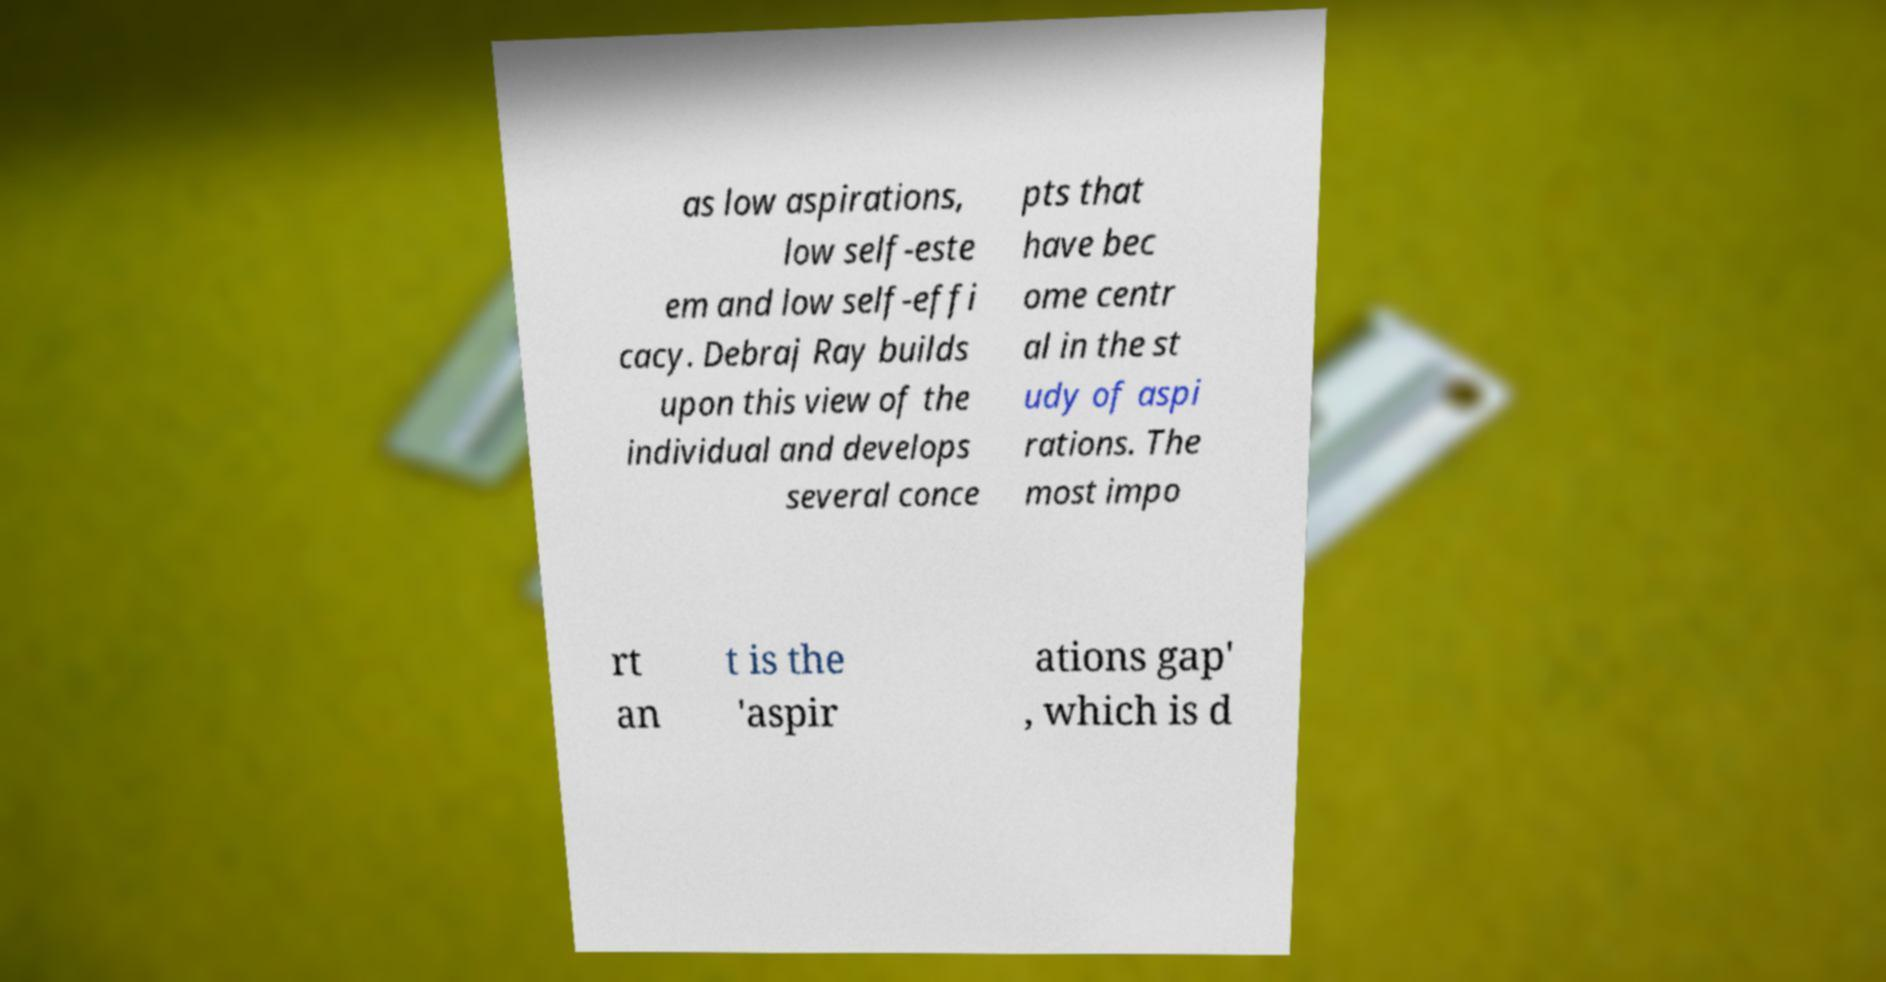Could you assist in decoding the text presented in this image and type it out clearly? as low aspirations, low self-este em and low self-effi cacy. Debraj Ray builds upon this view of the individual and develops several conce pts that have bec ome centr al in the st udy of aspi rations. The most impo rt an t is the 'aspir ations gap' , which is d 